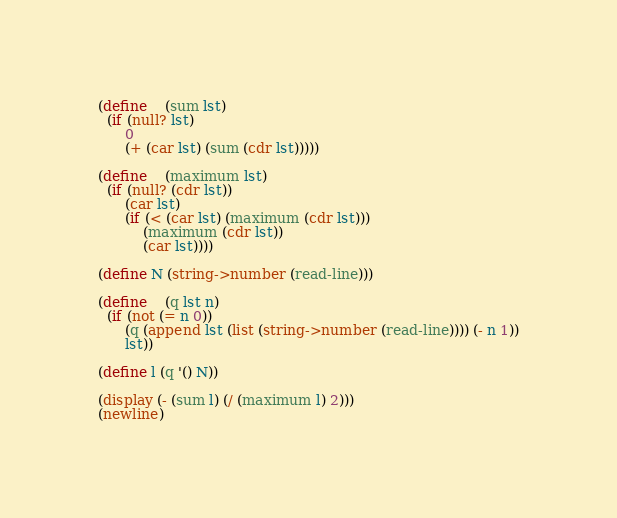<code> <loc_0><loc_0><loc_500><loc_500><_Scheme_>(define	(sum lst)
  (if (null? lst)
      0
      (+ (car lst) (sum (cdr lst)))))

(define	(maximum lst)
  (if (null? (cdr lst)) 
      (car lst)
      (if (< (car lst) (maximum (cdr lst)))
          (maximum (cdr lst))
          (car lst))))

(define N (string->number (read-line))) 

(define	(q lst n)
  (if (not (= n 0))
      (q (append lst (list (string->number (read-line)))) (- n 1))
      lst))

(define l (q '() N))

(display (- (sum l) (/ (maximum l) 2)))
(newline)</code> 